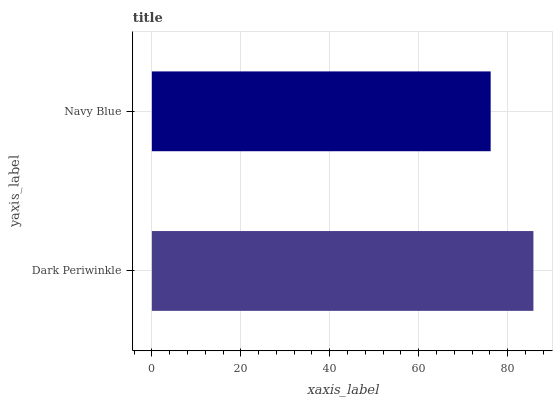Is Navy Blue the minimum?
Answer yes or no. Yes. Is Dark Periwinkle the maximum?
Answer yes or no. Yes. Is Navy Blue the maximum?
Answer yes or no. No. Is Dark Periwinkle greater than Navy Blue?
Answer yes or no. Yes. Is Navy Blue less than Dark Periwinkle?
Answer yes or no. Yes. Is Navy Blue greater than Dark Periwinkle?
Answer yes or no. No. Is Dark Periwinkle less than Navy Blue?
Answer yes or no. No. Is Dark Periwinkle the high median?
Answer yes or no. Yes. Is Navy Blue the low median?
Answer yes or no. Yes. Is Navy Blue the high median?
Answer yes or no. No. Is Dark Periwinkle the low median?
Answer yes or no. No. 